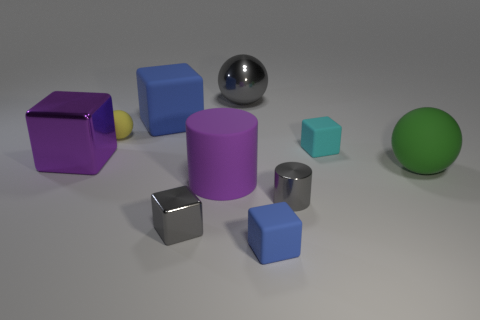There is a small rubber object that is the same shape as the large green thing; what color is it?
Make the answer very short. Yellow. The green ball has what size?
Give a very brief answer. Large. Are there fewer blue matte cubes that are behind the tiny cyan object than small green shiny cubes?
Your response must be concise. No. Do the gray cylinder and the large object to the left of the yellow rubber object have the same material?
Provide a short and direct response. Yes. There is a tiny metal thing to the right of the gray thing that is behind the small yellow matte thing; are there any blue objects on the left side of it?
Your answer should be very brief. Yes. Is there any other thing that has the same size as the metal cylinder?
Offer a very short reply. Yes. There is a cylinder that is the same material as the gray block; what is its color?
Offer a very short reply. Gray. How big is the matte thing that is to the right of the gray cylinder and behind the large metallic block?
Offer a terse response. Small. Are there fewer big gray metal balls that are on the right side of the large gray object than things that are in front of the yellow object?
Provide a short and direct response. Yes. Does the blue cube behind the purple matte cylinder have the same material as the gray thing that is left of the large gray metallic object?
Offer a terse response. No. 